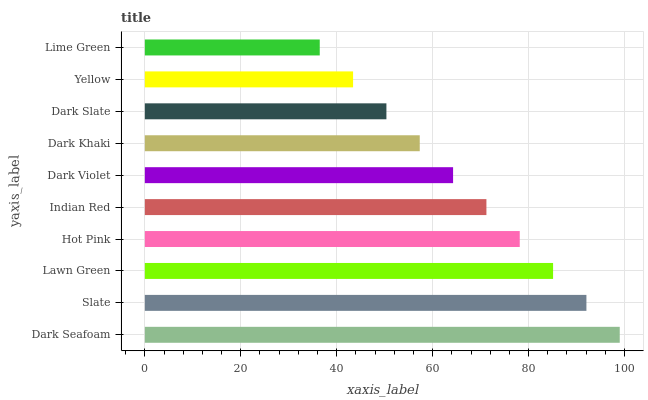Is Lime Green the minimum?
Answer yes or no. Yes. Is Dark Seafoam the maximum?
Answer yes or no. Yes. Is Slate the minimum?
Answer yes or no. No. Is Slate the maximum?
Answer yes or no. No. Is Dark Seafoam greater than Slate?
Answer yes or no. Yes. Is Slate less than Dark Seafoam?
Answer yes or no. Yes. Is Slate greater than Dark Seafoam?
Answer yes or no. No. Is Dark Seafoam less than Slate?
Answer yes or no. No. Is Indian Red the high median?
Answer yes or no. Yes. Is Dark Violet the low median?
Answer yes or no. Yes. Is Lime Green the high median?
Answer yes or no. No. Is Dark Slate the low median?
Answer yes or no. No. 